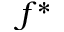<formula> <loc_0><loc_0><loc_500><loc_500>f ^ { * }</formula> 